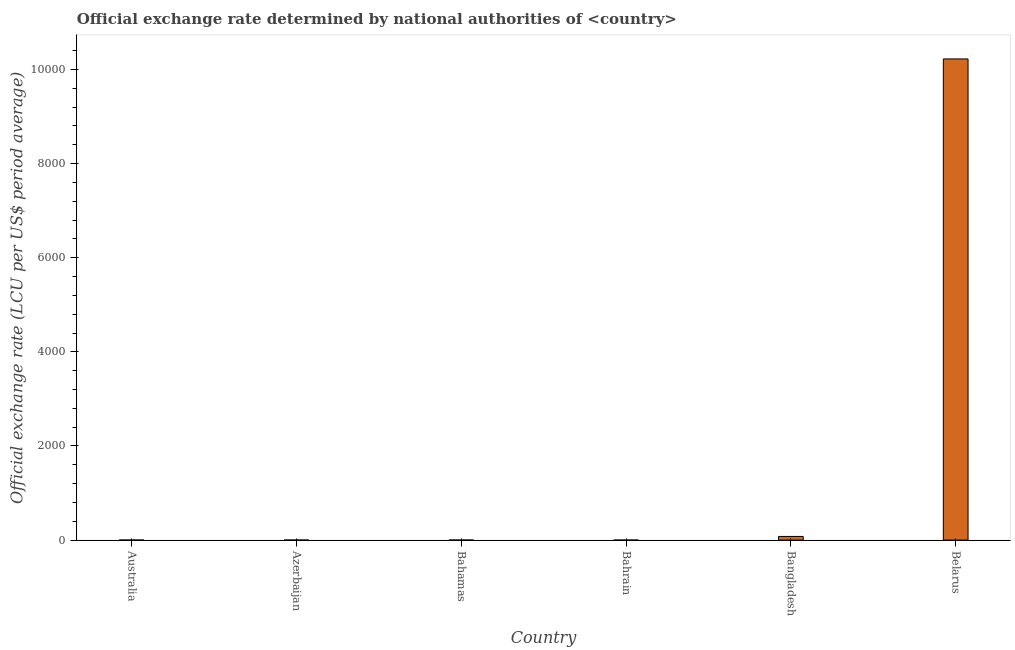What is the title of the graph?
Provide a short and direct response. Official exchange rate determined by national authorities of <country>. What is the label or title of the Y-axis?
Make the answer very short. Official exchange rate (LCU per US$ period average). What is the official exchange rate in Bangladesh?
Your response must be concise. 77.64. Across all countries, what is the maximum official exchange rate?
Keep it short and to the point. 1.02e+04. Across all countries, what is the minimum official exchange rate?
Provide a short and direct response. 0.38. In which country was the official exchange rate maximum?
Your answer should be compact. Belarus. In which country was the official exchange rate minimum?
Provide a succinct answer. Bahrain. What is the sum of the official exchange rate?
Your answer should be compact. 1.03e+04. What is the difference between the official exchange rate in Azerbaijan and Bahamas?
Give a very brief answer. -0.22. What is the average official exchange rate per country?
Provide a short and direct response. 1717.5. What is the median official exchange rate?
Your answer should be very brief. 1.05. What is the ratio of the official exchange rate in Australia to that in Bangladesh?
Your response must be concise. 0.01. Is the official exchange rate in Azerbaijan less than that in Belarus?
Provide a short and direct response. Yes. What is the difference between the highest and the second highest official exchange rate?
Offer a very short reply. 1.01e+04. What is the difference between the highest and the lowest official exchange rate?
Give a very brief answer. 1.02e+04. How many countries are there in the graph?
Your response must be concise. 6. What is the difference between two consecutive major ticks on the Y-axis?
Make the answer very short. 2000. Are the values on the major ticks of Y-axis written in scientific E-notation?
Give a very brief answer. No. What is the Official exchange rate (LCU per US$ period average) in Australia?
Provide a succinct answer. 1.11. What is the Official exchange rate (LCU per US$ period average) of Azerbaijan?
Your answer should be very brief. 0.78. What is the Official exchange rate (LCU per US$ period average) of Bahrain?
Offer a very short reply. 0.38. What is the Official exchange rate (LCU per US$ period average) in Bangladesh?
Provide a short and direct response. 77.64. What is the Official exchange rate (LCU per US$ period average) in Belarus?
Offer a very short reply. 1.02e+04. What is the difference between the Official exchange rate (LCU per US$ period average) in Australia and Azerbaijan?
Make the answer very short. 0.33. What is the difference between the Official exchange rate (LCU per US$ period average) in Australia and Bahamas?
Keep it short and to the point. 0.11. What is the difference between the Official exchange rate (LCU per US$ period average) in Australia and Bahrain?
Offer a very short reply. 0.73. What is the difference between the Official exchange rate (LCU per US$ period average) in Australia and Bangladesh?
Keep it short and to the point. -76.53. What is the difference between the Official exchange rate (LCU per US$ period average) in Australia and Belarus?
Offer a very short reply. -1.02e+04. What is the difference between the Official exchange rate (LCU per US$ period average) in Azerbaijan and Bahamas?
Make the answer very short. -0.22. What is the difference between the Official exchange rate (LCU per US$ period average) in Azerbaijan and Bahrain?
Offer a very short reply. 0.41. What is the difference between the Official exchange rate (LCU per US$ period average) in Azerbaijan and Bangladesh?
Provide a succinct answer. -76.86. What is the difference between the Official exchange rate (LCU per US$ period average) in Azerbaijan and Belarus?
Make the answer very short. -1.02e+04. What is the difference between the Official exchange rate (LCU per US$ period average) in Bahamas and Bahrain?
Your answer should be compact. 0.62. What is the difference between the Official exchange rate (LCU per US$ period average) in Bahamas and Bangladesh?
Make the answer very short. -76.64. What is the difference between the Official exchange rate (LCU per US$ period average) in Bahamas and Belarus?
Your response must be concise. -1.02e+04. What is the difference between the Official exchange rate (LCU per US$ period average) in Bahrain and Bangladesh?
Your response must be concise. -77.27. What is the difference between the Official exchange rate (LCU per US$ period average) in Bahrain and Belarus?
Your answer should be compact. -1.02e+04. What is the difference between the Official exchange rate (LCU per US$ period average) in Bangladesh and Belarus?
Keep it short and to the point. -1.01e+04. What is the ratio of the Official exchange rate (LCU per US$ period average) in Australia to that in Azerbaijan?
Your answer should be very brief. 1.41. What is the ratio of the Official exchange rate (LCU per US$ period average) in Australia to that in Bahamas?
Offer a very short reply. 1.11. What is the ratio of the Official exchange rate (LCU per US$ period average) in Australia to that in Bahrain?
Make the answer very short. 2.95. What is the ratio of the Official exchange rate (LCU per US$ period average) in Australia to that in Bangladesh?
Ensure brevity in your answer.  0.01. What is the ratio of the Official exchange rate (LCU per US$ period average) in Australia to that in Belarus?
Give a very brief answer. 0. What is the ratio of the Official exchange rate (LCU per US$ period average) in Azerbaijan to that in Bahamas?
Offer a very short reply. 0.78. What is the ratio of the Official exchange rate (LCU per US$ period average) in Azerbaijan to that in Bahrain?
Ensure brevity in your answer.  2.09. What is the ratio of the Official exchange rate (LCU per US$ period average) in Bahamas to that in Bahrain?
Offer a terse response. 2.66. What is the ratio of the Official exchange rate (LCU per US$ period average) in Bahamas to that in Bangladesh?
Provide a succinct answer. 0.01. What is the ratio of the Official exchange rate (LCU per US$ period average) in Bahrain to that in Bangladesh?
Your answer should be very brief. 0.01. What is the ratio of the Official exchange rate (LCU per US$ period average) in Bangladesh to that in Belarus?
Give a very brief answer. 0.01. 